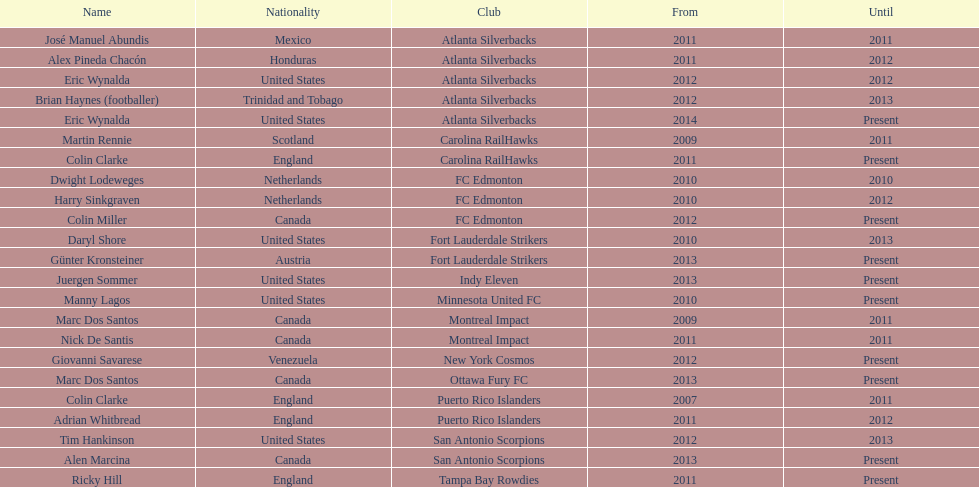What same country did marc dos santos coach as colin miller? Canada. 